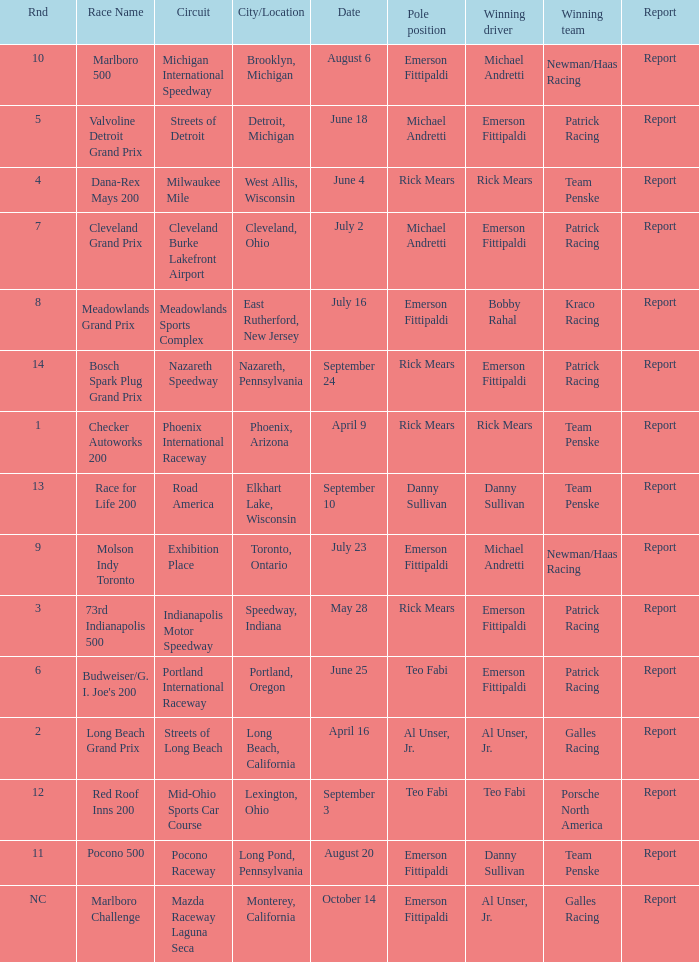How many winning drivers were the for the rnd equalling 5? 1.0. 